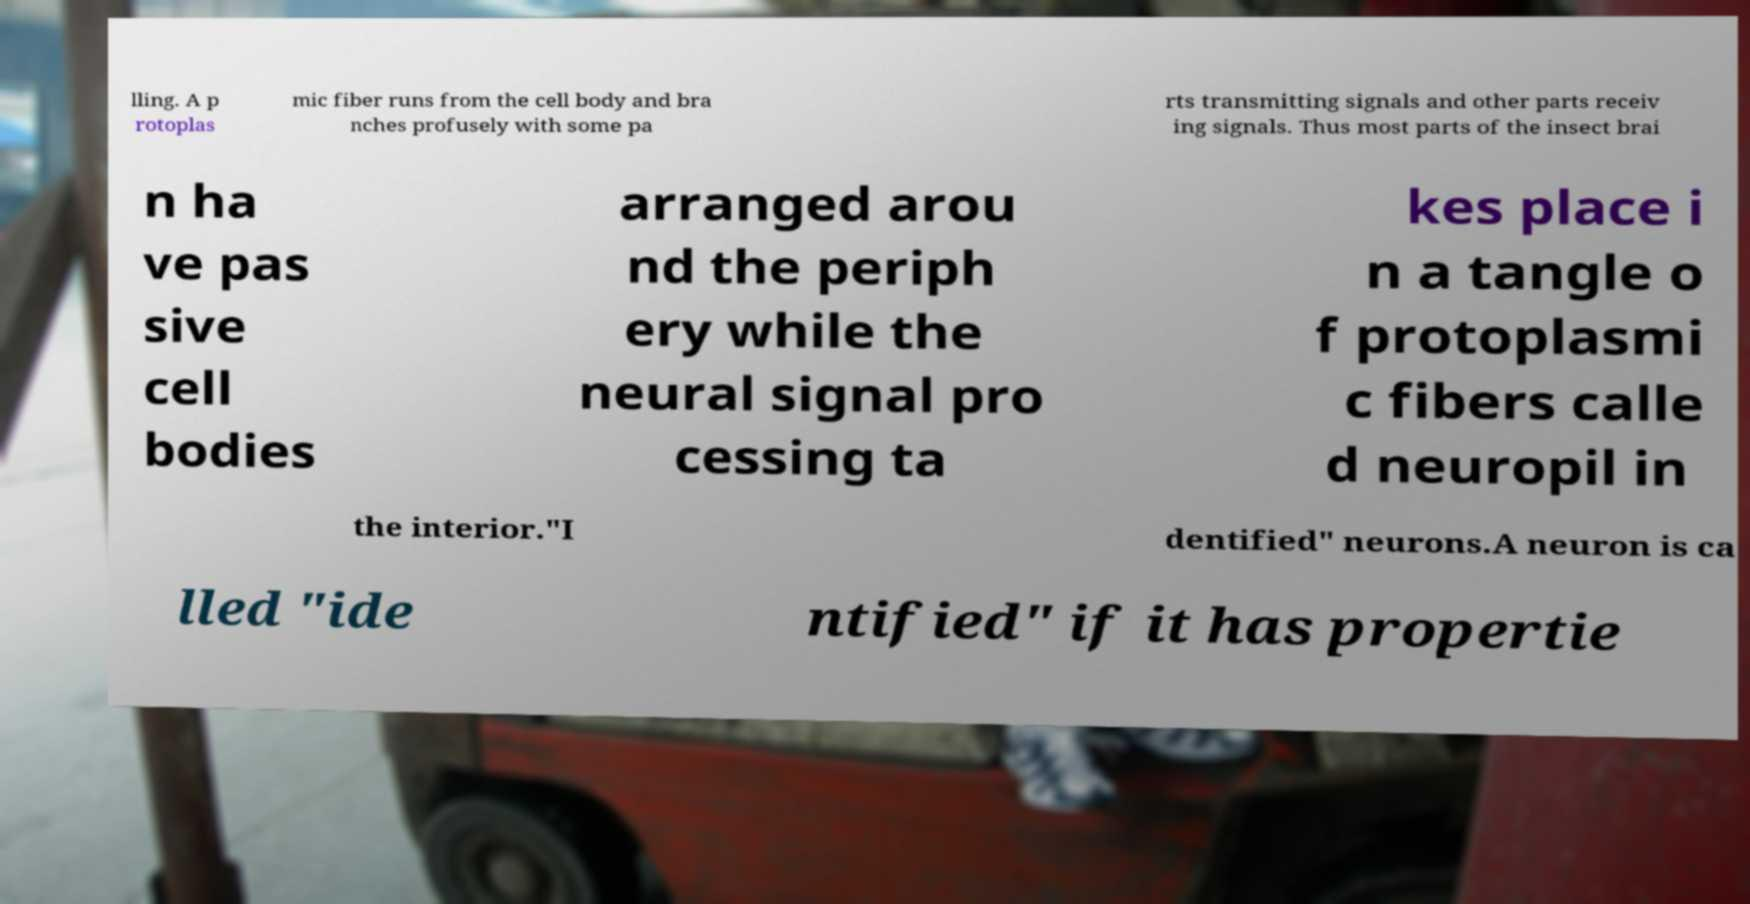Could you assist in decoding the text presented in this image and type it out clearly? lling. A p rotoplas mic fiber runs from the cell body and bra nches profusely with some pa rts transmitting signals and other parts receiv ing signals. Thus most parts of the insect brai n ha ve pas sive cell bodies arranged arou nd the periph ery while the neural signal pro cessing ta kes place i n a tangle o f protoplasmi c fibers calle d neuropil in the interior."I dentified" neurons.A neuron is ca lled "ide ntified" if it has propertie 